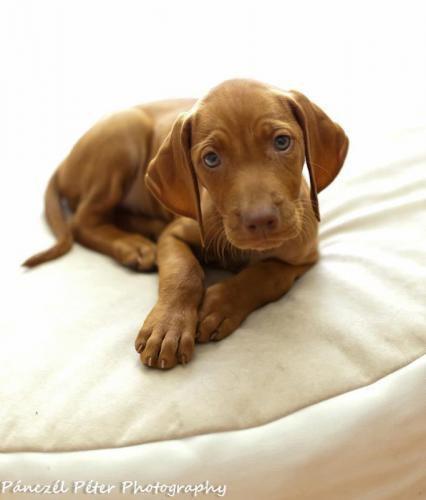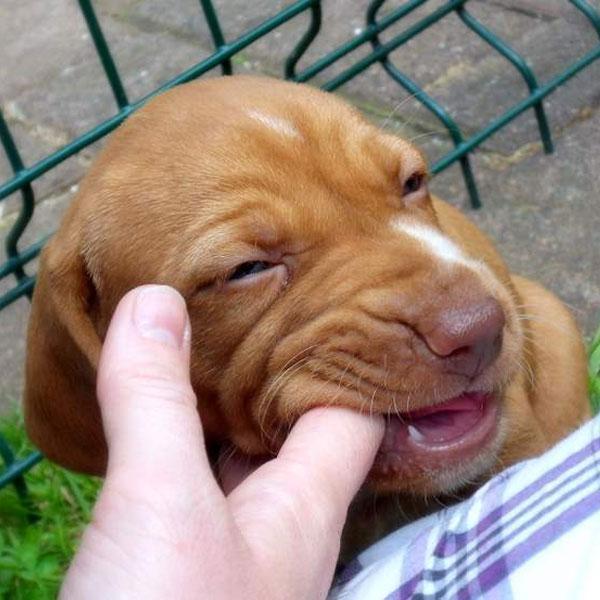The first image is the image on the left, the second image is the image on the right. Considering the images on both sides, is "The right image features one camera-gazing puppy with fully open eyes, and the left image features one reclining puppy with its front paws forward." valid? Answer yes or no. No. The first image is the image on the left, the second image is the image on the right. Examine the images to the left and right. Is the description "A dog is wearing a collar." accurate? Answer yes or no. No. 